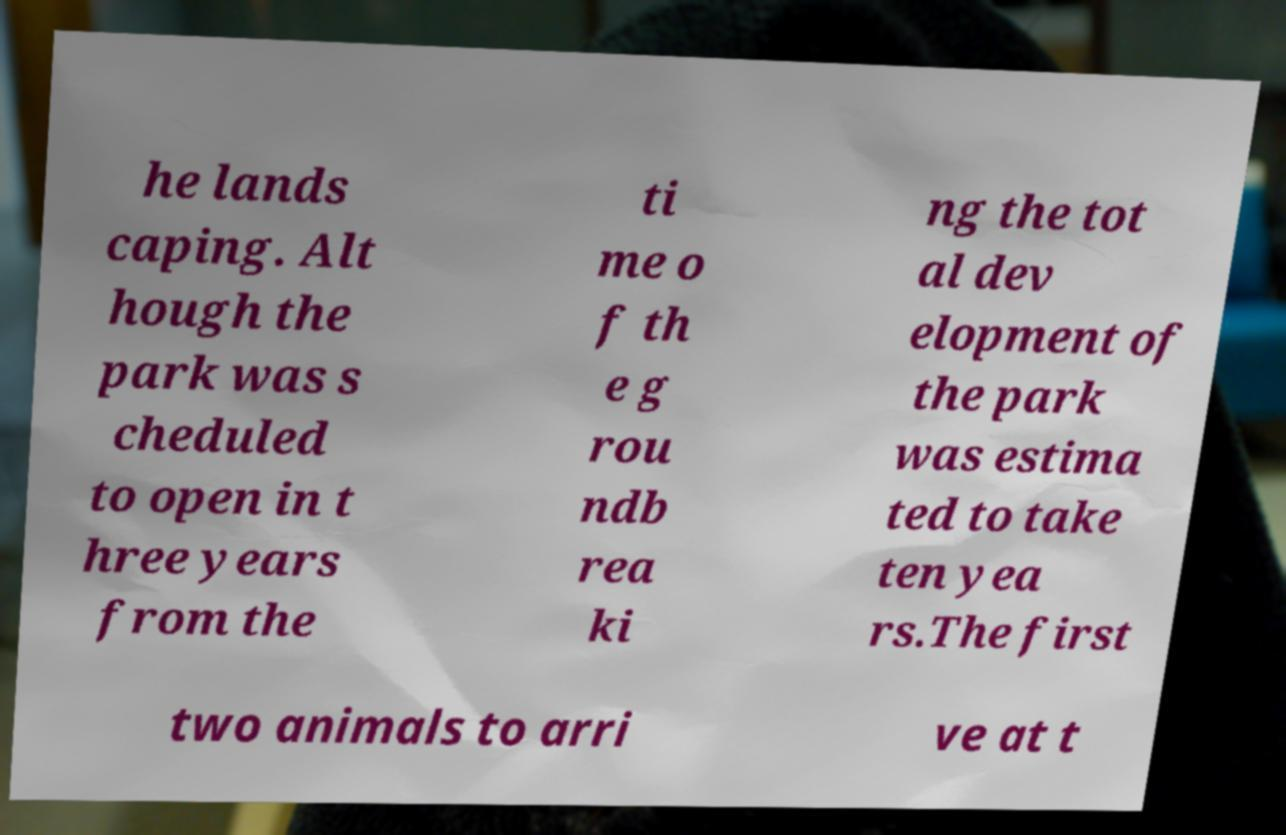Please identify and transcribe the text found in this image. he lands caping. Alt hough the park was s cheduled to open in t hree years from the ti me o f th e g rou ndb rea ki ng the tot al dev elopment of the park was estima ted to take ten yea rs.The first two animals to arri ve at t 